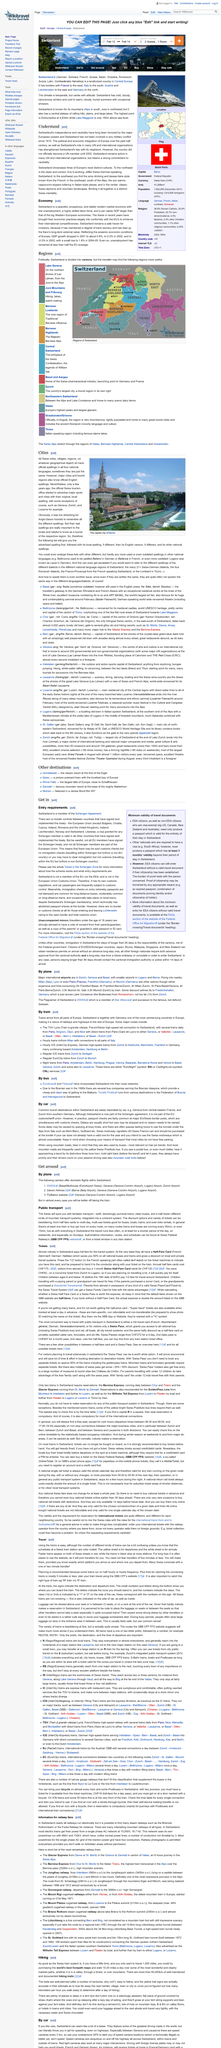Indicate a few pertinent items in this graphic. This page is about Switzerland. The capital city of Berne is known as "The capital city of Berne". The title of this page is "Cities. 